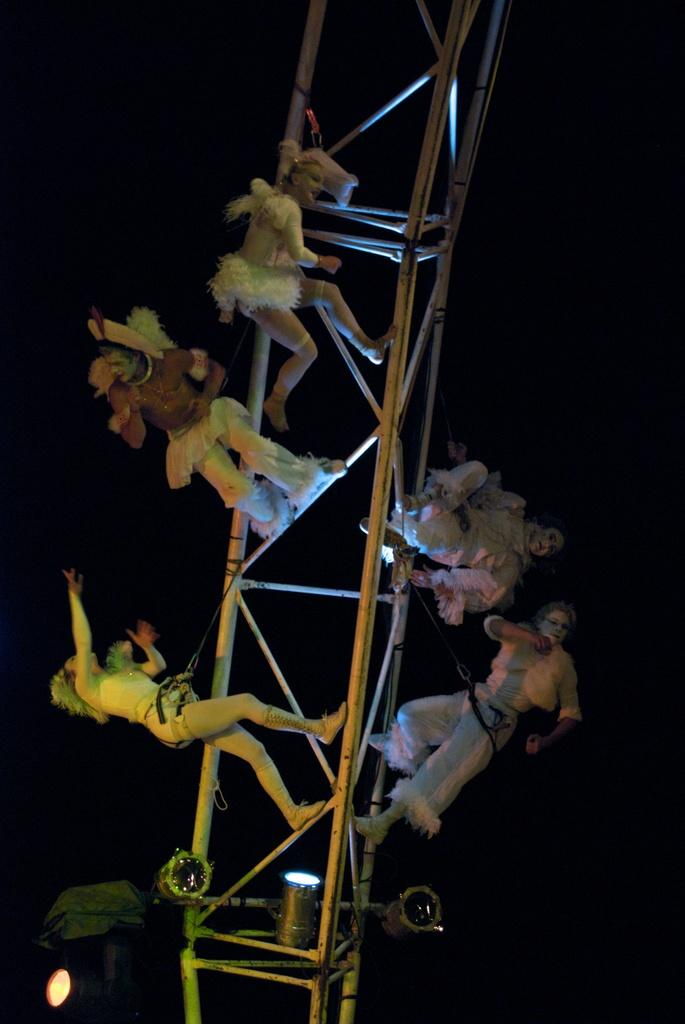What is the main subject of the image? The main subject of the image is a person. What is the person holding in the image? The person is holding a metal frame. Can you tell me how the person is measuring the distance to the moon in the image? There is no indication in the image that the person is measuring the distance to the moon. 